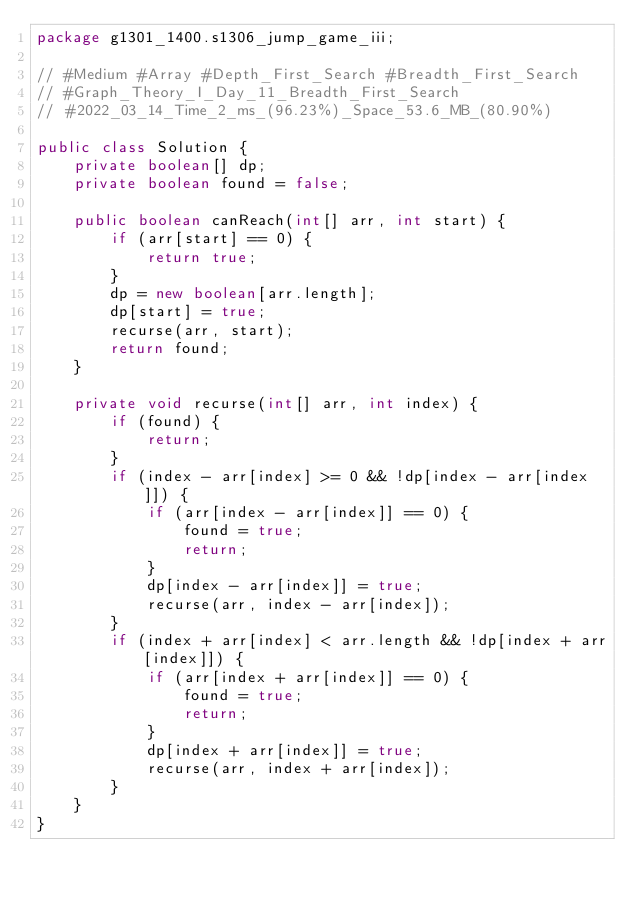<code> <loc_0><loc_0><loc_500><loc_500><_Java_>package g1301_1400.s1306_jump_game_iii;

// #Medium #Array #Depth_First_Search #Breadth_First_Search
// #Graph_Theory_I_Day_11_Breadth_First_Search
// #2022_03_14_Time_2_ms_(96.23%)_Space_53.6_MB_(80.90%)

public class Solution {
    private boolean[] dp;
    private boolean found = false;

    public boolean canReach(int[] arr, int start) {
        if (arr[start] == 0) {
            return true;
        }
        dp = new boolean[arr.length];
        dp[start] = true;
        recurse(arr, start);
        return found;
    }

    private void recurse(int[] arr, int index) {
        if (found) {
            return;
        }
        if (index - arr[index] >= 0 && !dp[index - arr[index]]) {
            if (arr[index - arr[index]] == 0) {
                found = true;
                return;
            }
            dp[index - arr[index]] = true;
            recurse(arr, index - arr[index]);
        }
        if (index + arr[index] < arr.length && !dp[index + arr[index]]) {
            if (arr[index + arr[index]] == 0) {
                found = true;
                return;
            }
            dp[index + arr[index]] = true;
            recurse(arr, index + arr[index]);
        }
    }
}
</code> 